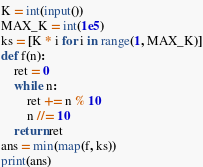<code> <loc_0><loc_0><loc_500><loc_500><_Python_>K = int(input())
MAX_K = int(1e5)
ks = [K * i for i in range(1, MAX_K)]
def f(n):
    ret = 0
    while n:
        ret += n % 10
        n //= 10
    return ret
ans = min(map(f, ks))
print(ans)
</code> 